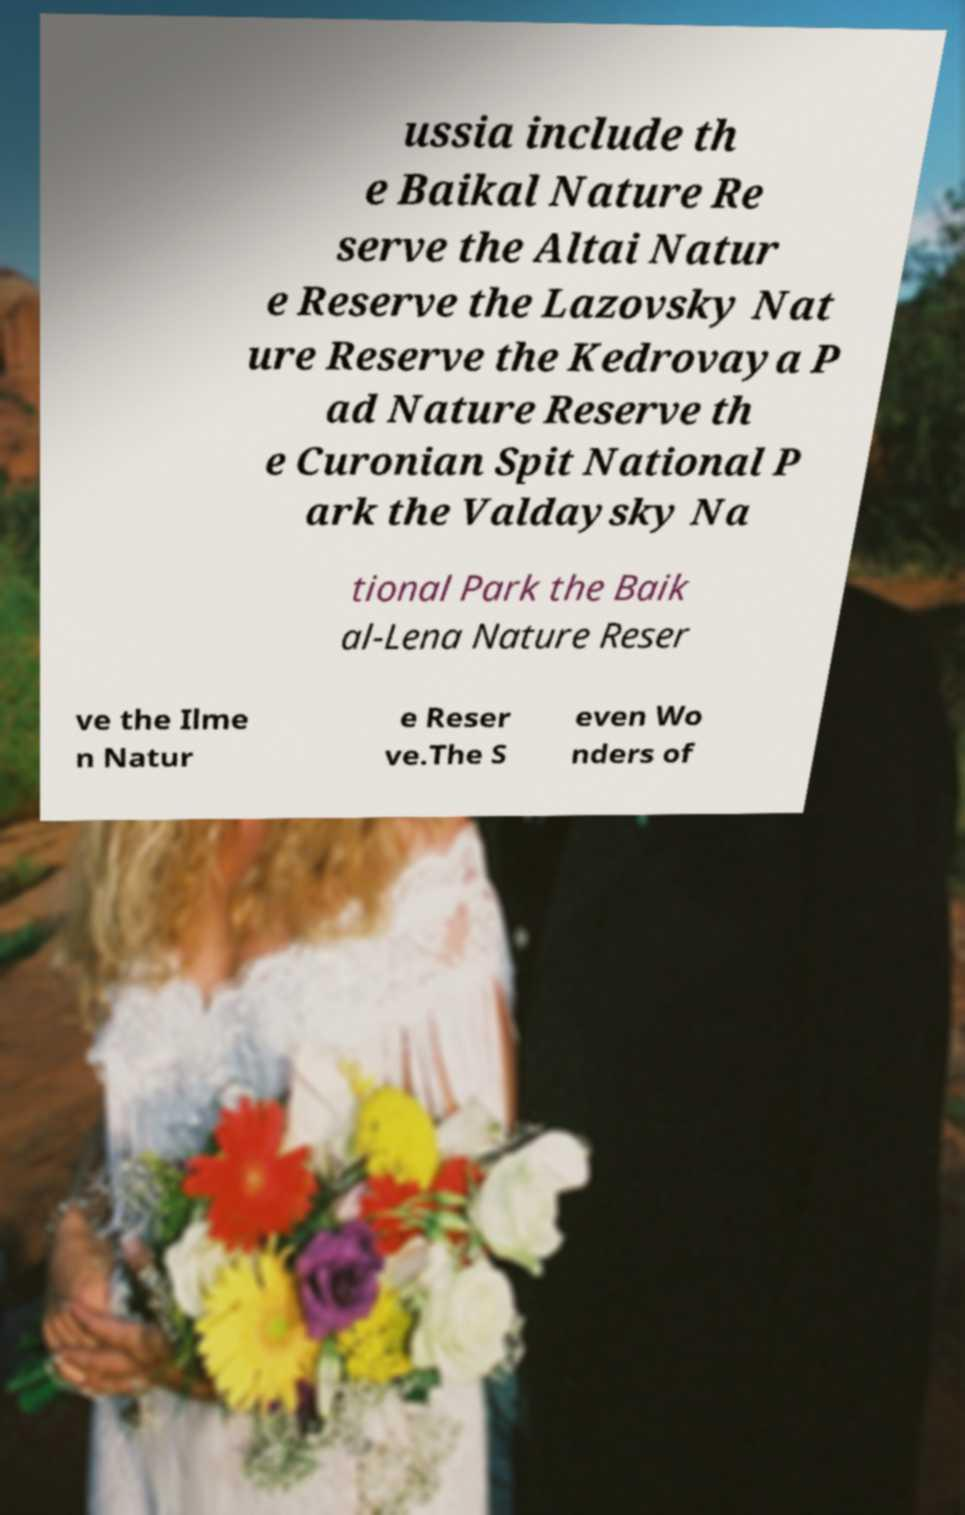Could you assist in decoding the text presented in this image and type it out clearly? ussia include th e Baikal Nature Re serve the Altai Natur e Reserve the Lazovsky Nat ure Reserve the Kedrovaya P ad Nature Reserve th e Curonian Spit National P ark the Valdaysky Na tional Park the Baik al-Lena Nature Reser ve the Ilme n Natur e Reser ve.The S even Wo nders of 